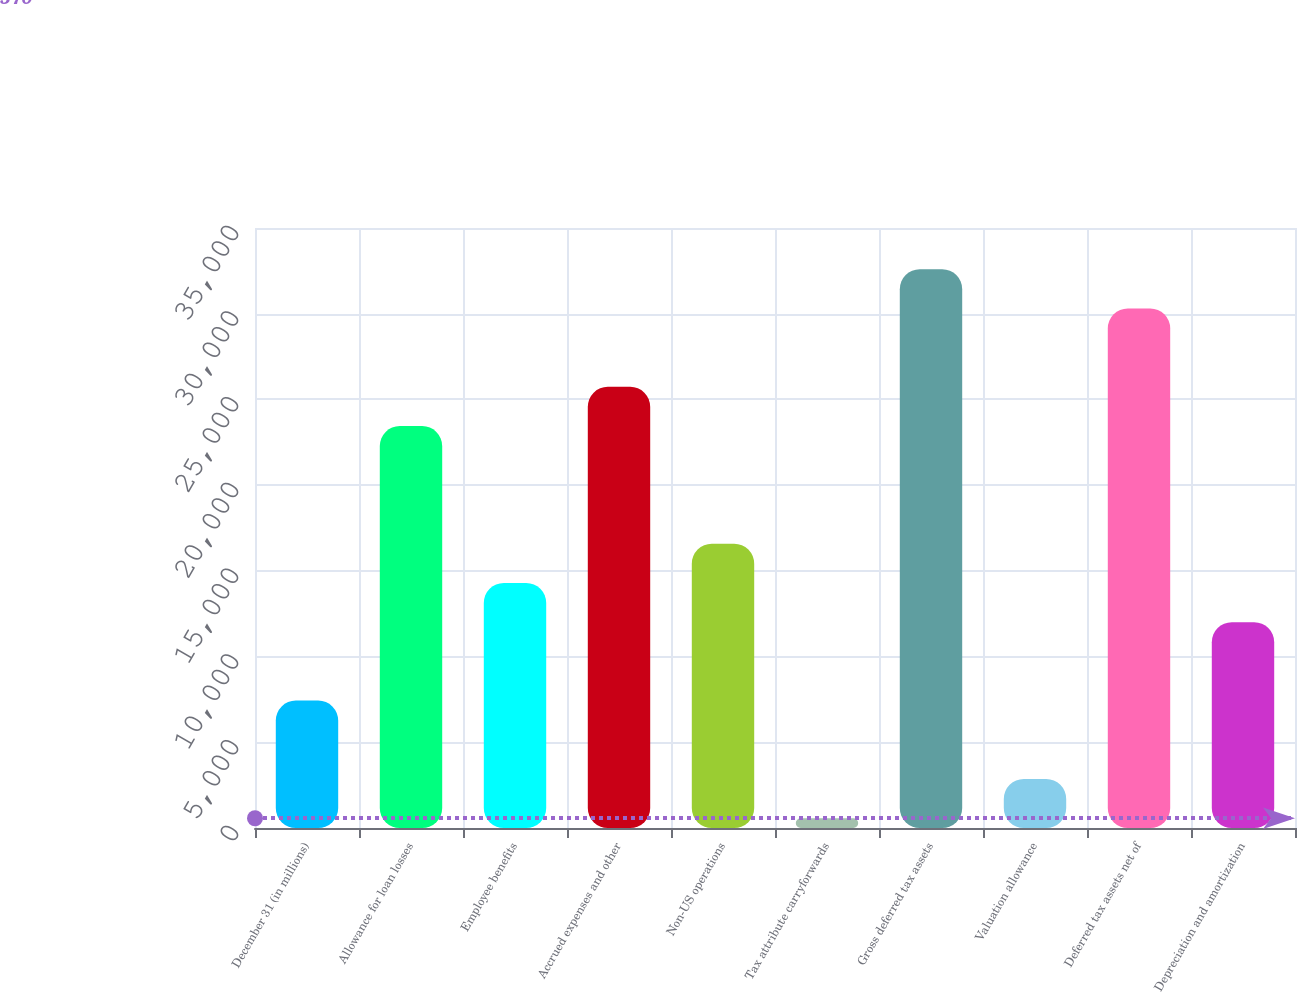<chart> <loc_0><loc_0><loc_500><loc_500><bar_chart><fcel>December 31 (in millions)<fcel>Allowance for loan losses<fcel>Employee benefits<fcel>Accrued expenses and other<fcel>Non-US operations<fcel>Tax attribute carryforwards<fcel>Gross deferred tax assets<fcel>Valuation allowance<fcel>Deferred tax assets net of<fcel>Depreciation and amortization<nl><fcel>7433.1<fcel>23447<fcel>14296.2<fcel>25734.7<fcel>16583.9<fcel>570<fcel>32597.8<fcel>2857.7<fcel>30310.1<fcel>12008.5<nl></chart> 